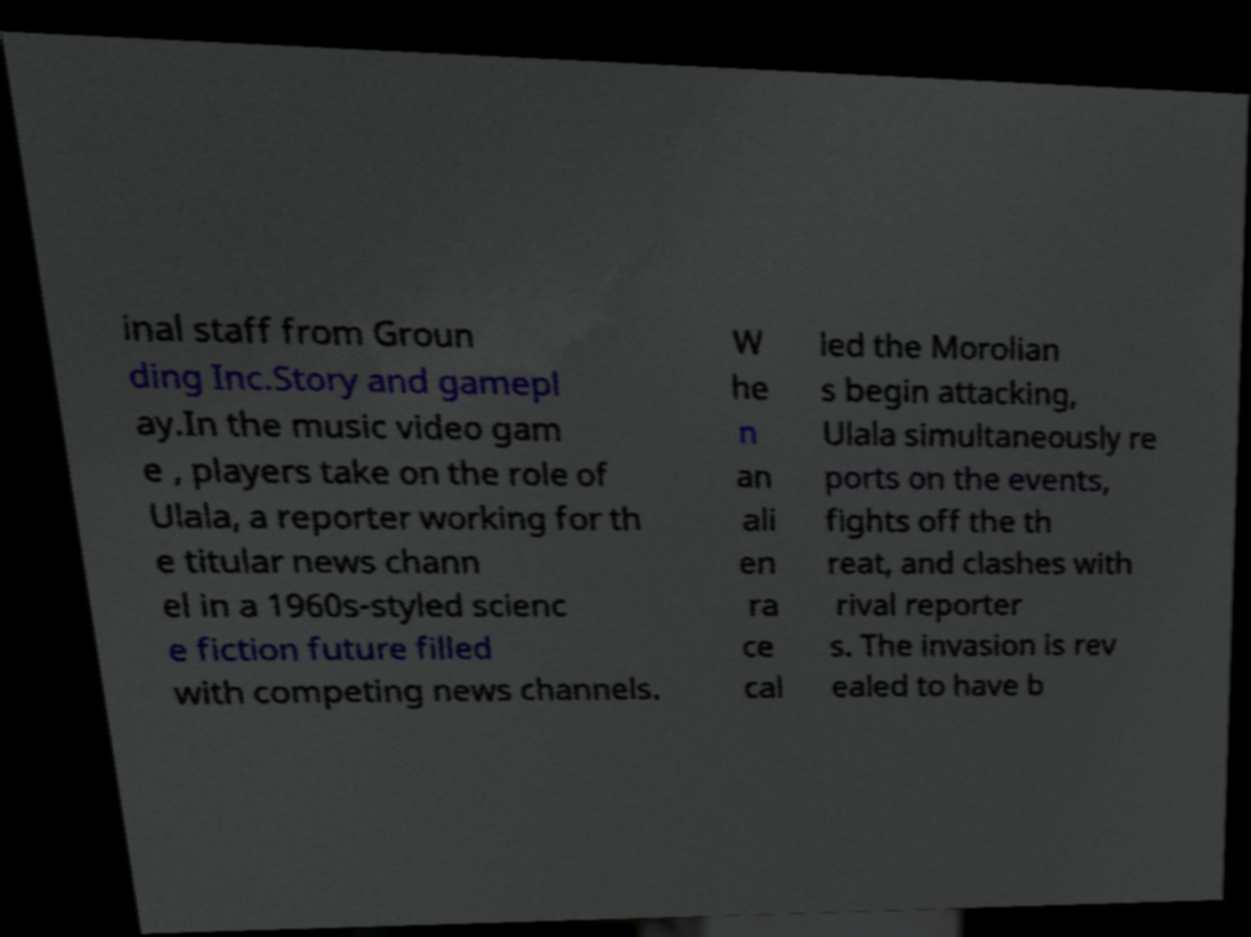There's text embedded in this image that I need extracted. Can you transcribe it verbatim? inal staff from Groun ding Inc.Story and gamepl ay.In the music video gam e , players take on the role of Ulala, a reporter working for th e titular news chann el in a 1960s-styled scienc e fiction future filled with competing news channels. W he n an ali en ra ce cal led the Morolian s begin attacking, Ulala simultaneously re ports on the events, fights off the th reat, and clashes with rival reporter s. The invasion is rev ealed to have b 